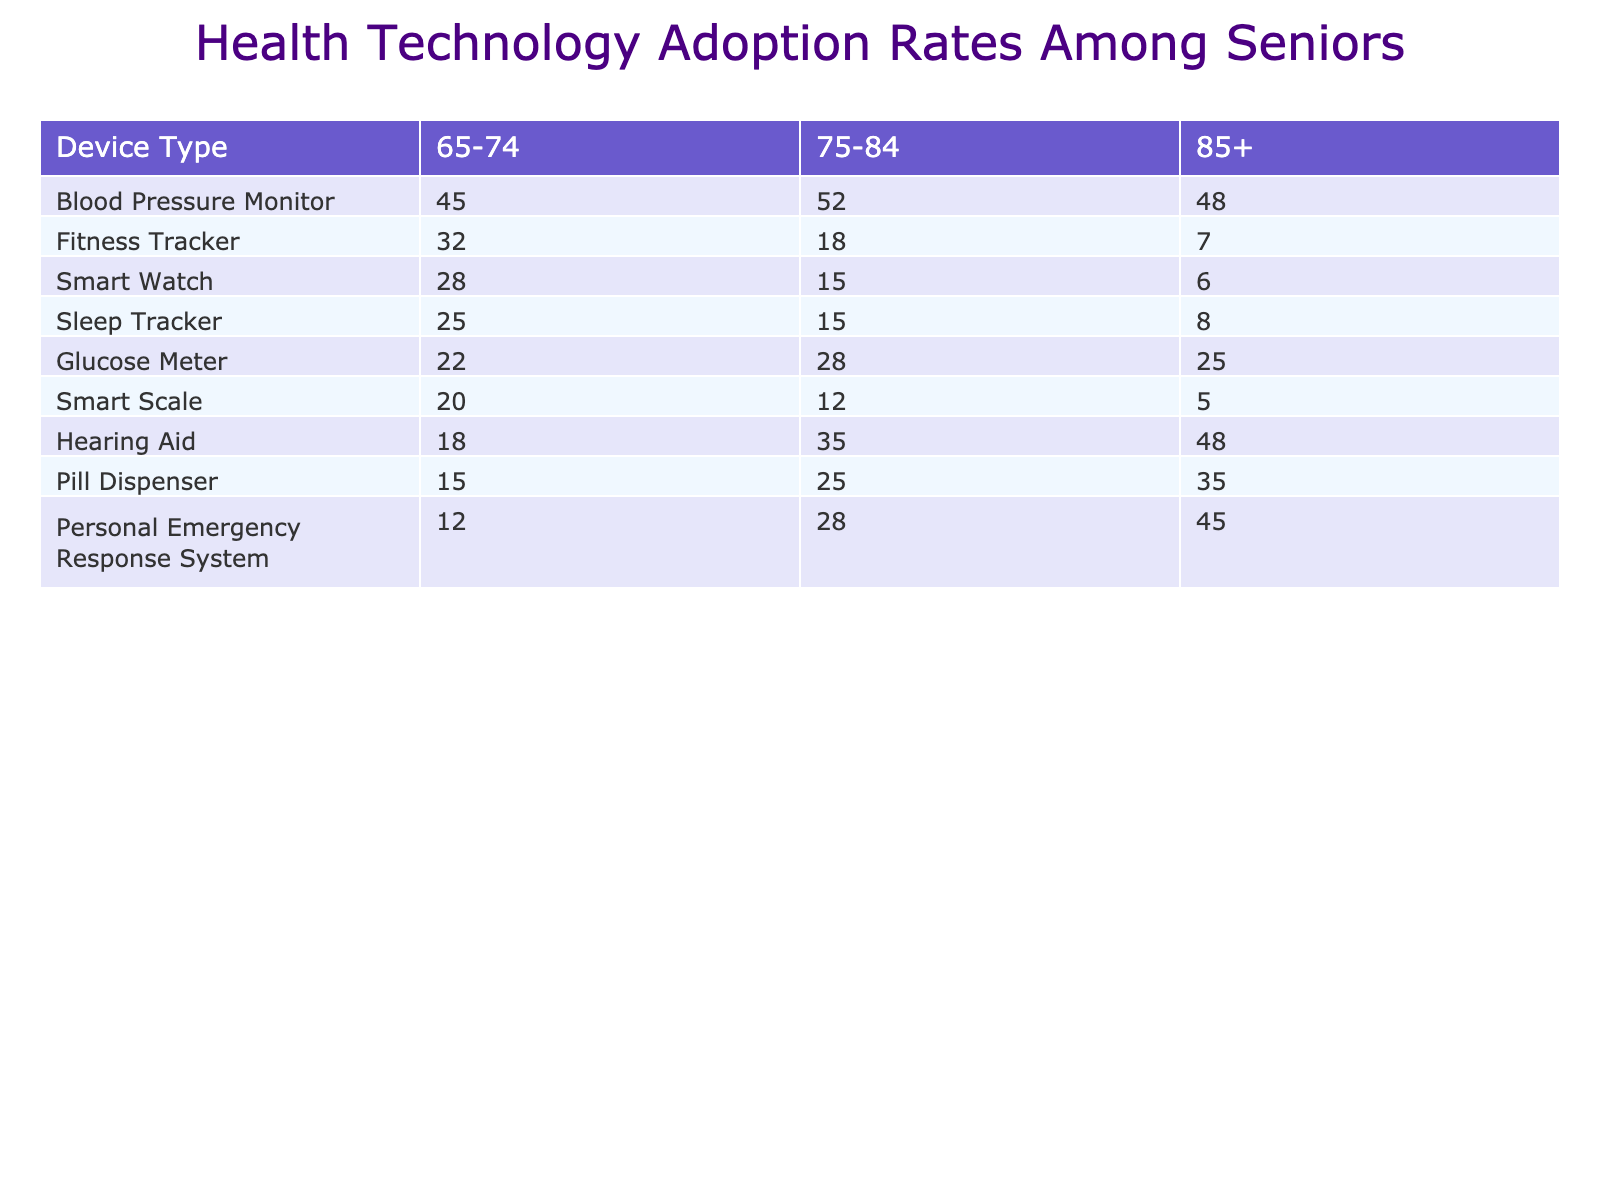What is the adoption rate of Blood Pressure Monitors among seniors aged 75-84? The table shows that the adoption rate for Blood Pressure Monitors in the age group 75-84 is 52%.
Answer: 52% Which device type has the highest adoption rate for the age group 65-74? Looking at the table, Blood Pressure Monitors have the highest adoption rate at 45% for the age group 65-74.
Answer: Blood Pressure Monitor Is the adoption rate of Smart Watches higher for seniors aged 75-84 compared to those aged 85 and above? For the age group 75-84, the adoption rate of Smart Watches is 15%, whereas for the age group 85+, it is 6%. Since 15% is higher than 6%, the answer is yes.
Answer: Yes What is the difference in adoption rates of Pill Dispensers between the age groups 75-84 and 85+? The adoption rate for Pill Dispensers in the age group 75-84 is 25% and for 85+ it is 35%. The difference is calculated as 35% - 25% = 10%.
Answer: 10% Are seniors aged 85 and above more likely to use Hearing Aids than Fitness Trackers? The adoption rate for Hearing Aids among seniors aged 85+ is 48%, while for Fitness Trackers it is 7%. Since 48% is greater than 7%, the answer is yes.
Answer: Yes What is the average adoption rate of Sleep Trackers across all age groups? The adoption rates for Sleep Trackers are 25% (65-74), 15% (75-84), and 8% (85+). The sum of these values is 25 + 15 + 8 = 48. To find the average, divide 48 by 3 (the number of age groups), which gives 16.
Answer: 16 Which device has the lowest adoption rate for seniors aged 85 and above? The table shows that the adoption rates for various devices among seniors aged 85+ are: Fitness Tracker (7%), Smart Watch (6%), Blood Pressure Monitor (48%), Glucose Meter (25%), Pill Dispenser (35%), Hearing Aid (48%), Personal Emergency Response System (45%), Smart Scale (5%), and Sleep Tracker (8%). The lowest is 5% for Smart Scale.
Answer: Smart Scale What can be inferred about the trend of adoption rates as age increases across the studied devices? By comparing the adoption rates across age groups and devices in the table, it is notable that adoption rates generally decrease as age increases for devices like Fitness Trackers and Smart Scales, while some devices like Hearing Aids and Blood Pressure Monitors have higher rates among older age groups. This indicates varying trends based on device type.
Answer: Adoption rates decrease for some devices but vary for others 